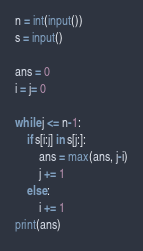Convert code to text. <code><loc_0><loc_0><loc_500><loc_500><_Python_>n = int(input())
s = input()

ans = 0
i = j= 0

while j <= n-1:
    if s[i:j] in s[j:]:
        ans = max(ans, j-i)
        j += 1
    else:
        i += 1
print(ans)</code> 